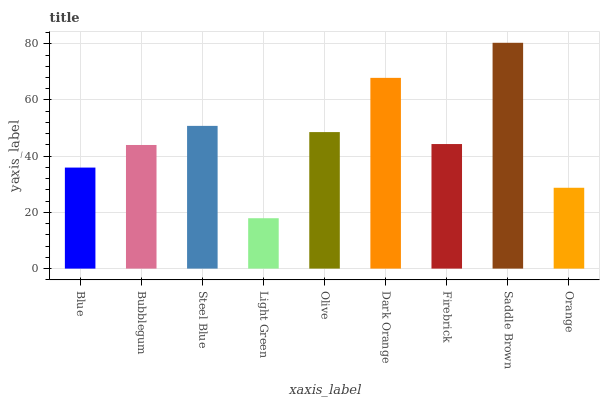Is Light Green the minimum?
Answer yes or no. Yes. Is Saddle Brown the maximum?
Answer yes or no. Yes. Is Bubblegum the minimum?
Answer yes or no. No. Is Bubblegum the maximum?
Answer yes or no. No. Is Bubblegum greater than Blue?
Answer yes or no. Yes. Is Blue less than Bubblegum?
Answer yes or no. Yes. Is Blue greater than Bubblegum?
Answer yes or no. No. Is Bubblegum less than Blue?
Answer yes or no. No. Is Firebrick the high median?
Answer yes or no. Yes. Is Firebrick the low median?
Answer yes or no. Yes. Is Orange the high median?
Answer yes or no. No. Is Bubblegum the low median?
Answer yes or no. No. 